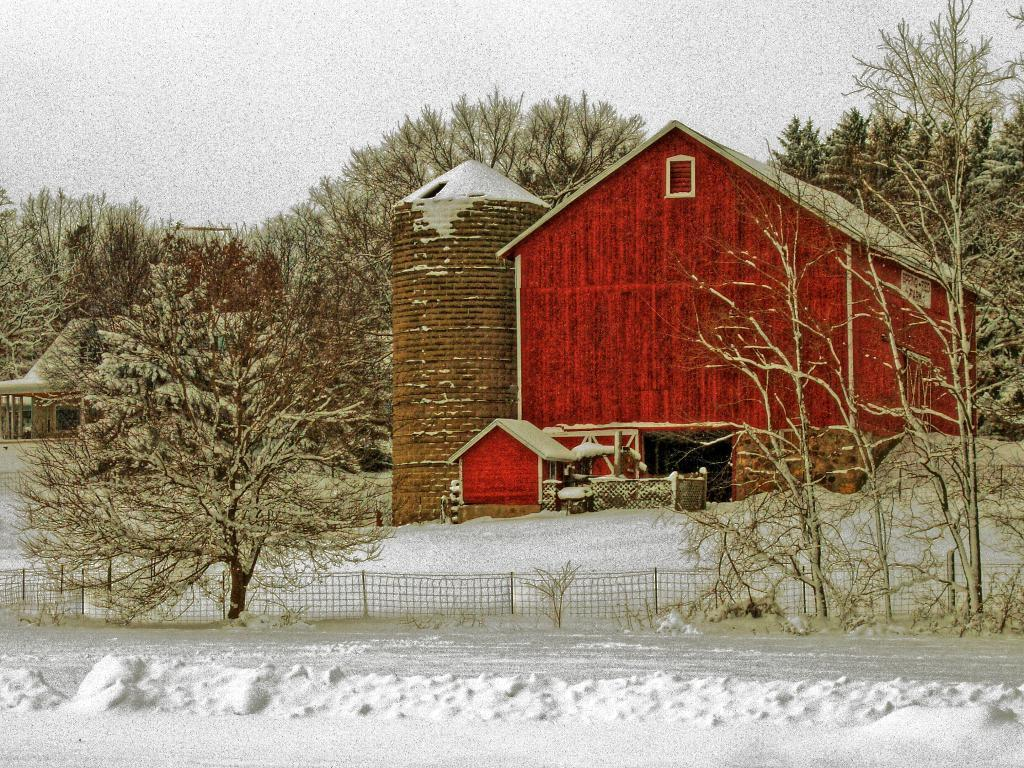What is the color of the house in the image? The house in the image is red. What type of vegetation can be seen in the image? There are trees in the image. What is the purpose of the structure surrounding the house? There is a fence in the image, which may serve as a boundary or barrier. What is the weather like in the image? There is snow visible in the image, indicating a cold or wintry environment. What is visible in the background of the image? The sky is visible in the background of the image. What type of chain can be seen connecting the house to the prison in the image? There is no chain or prison present in the image; it features a red house with trees, a fence, snow, and a visible sky. 